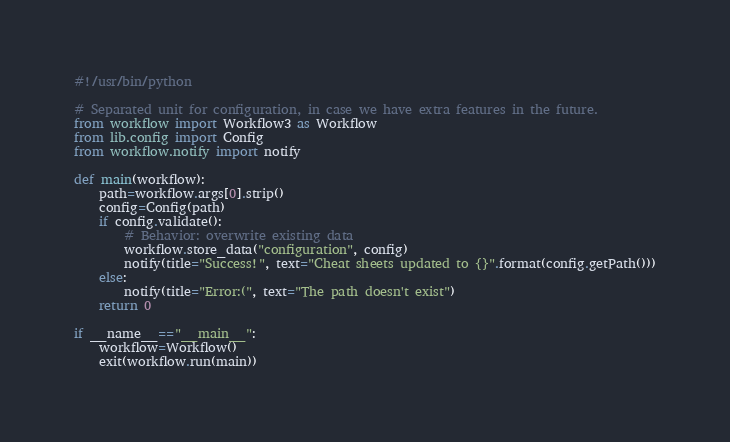<code> <loc_0><loc_0><loc_500><loc_500><_Python_>#!/usr/bin/python

# Separated unit for configuration, in case we have extra features in the future.
from workflow import Workflow3 as Workflow
from lib.config import Config
from workflow.notify import notify

def main(workflow):
    path=workflow.args[0].strip()
    config=Config(path)
    if config.validate():
        # Behavior: overwrite existing data
        workflow.store_data("configuration", config)
        notify(title="Success!", text="Cheat sheets updated to {}".format(config.getPath()))
    else:
        notify(title="Error:(", text="The path doesn't exist")
    return 0

if __name__=="__main__":
    workflow=Workflow()
    exit(workflow.run(main))
</code> 